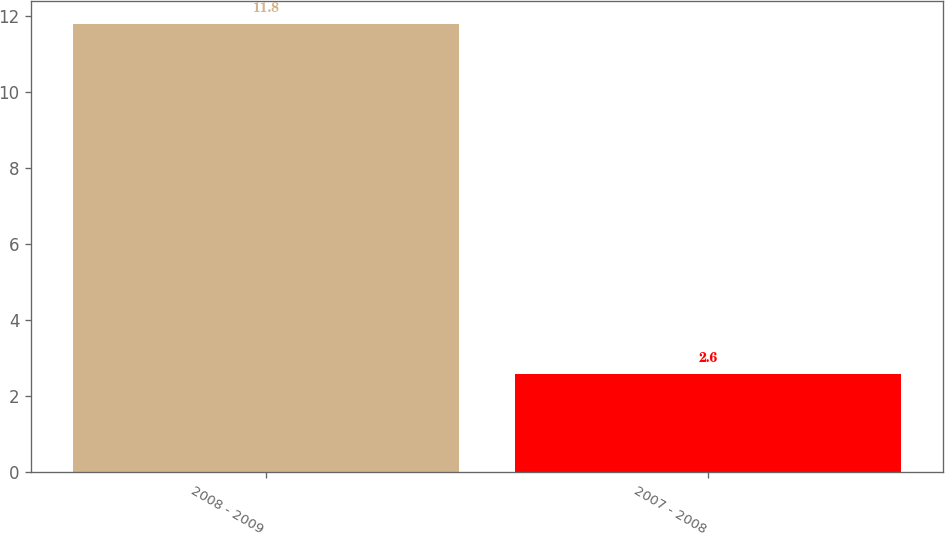Convert chart. <chart><loc_0><loc_0><loc_500><loc_500><bar_chart><fcel>2008 - 2009<fcel>2007 - 2008<nl><fcel>11.8<fcel>2.6<nl></chart> 